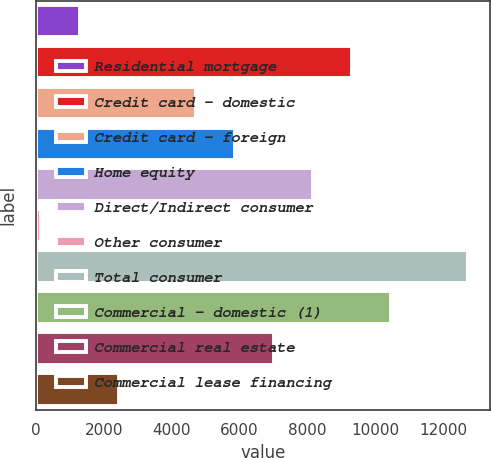Convert chart. <chart><loc_0><loc_0><loc_500><loc_500><bar_chart><fcel>Residential mortgage<fcel>Credit card - domestic<fcel>Credit card - foreign<fcel>Home equity<fcel>Direct/Indirect consumer<fcel>Other consumer<fcel>Total consumer<fcel>Commercial - domestic (1)<fcel>Commercial real estate<fcel>Commercial lease financing<nl><fcel>1294.7<fcel>9300.6<fcel>4725.8<fcel>5869.5<fcel>8156.9<fcel>151<fcel>12731.7<fcel>10444.3<fcel>7013.2<fcel>2438.4<nl></chart> 